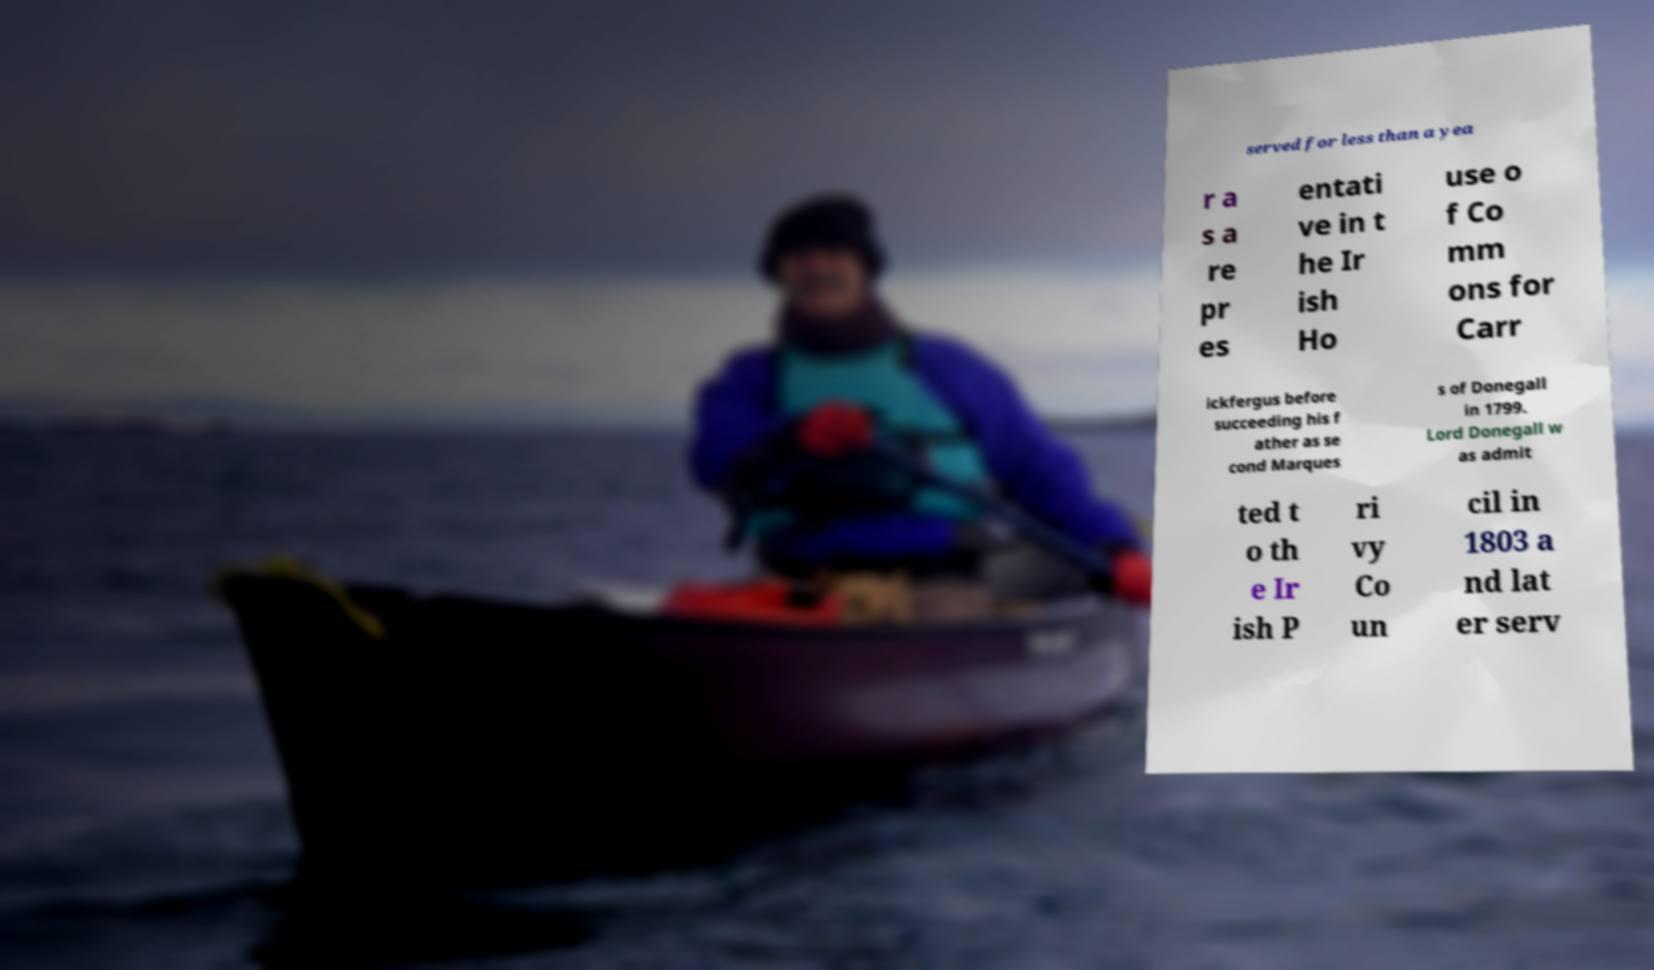Could you extract and type out the text from this image? served for less than a yea r a s a re pr es entati ve in t he Ir ish Ho use o f Co mm ons for Carr ickfergus before succeeding his f ather as se cond Marques s of Donegall in 1799. Lord Donegall w as admit ted t o th e Ir ish P ri vy Co un cil in 1803 a nd lat er serv 